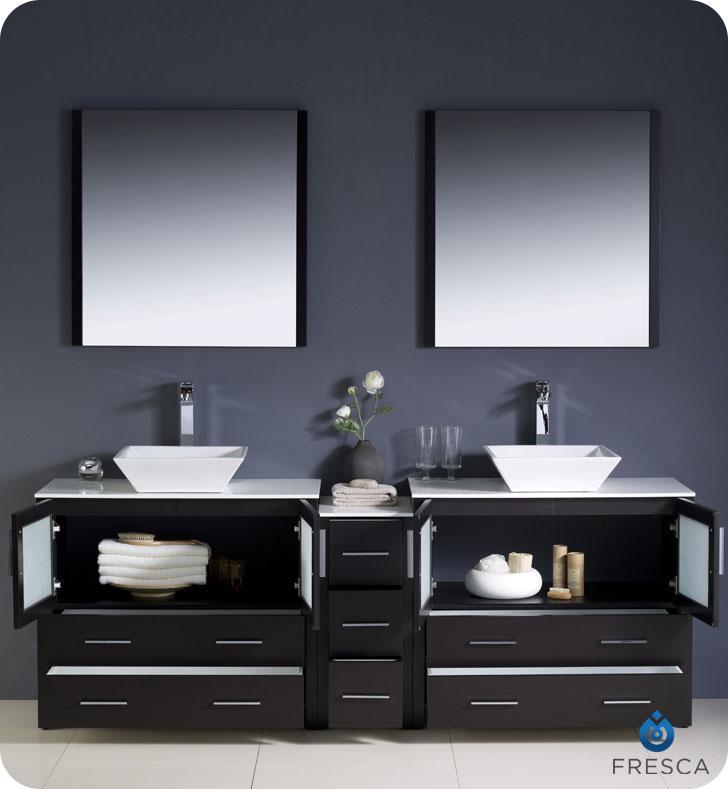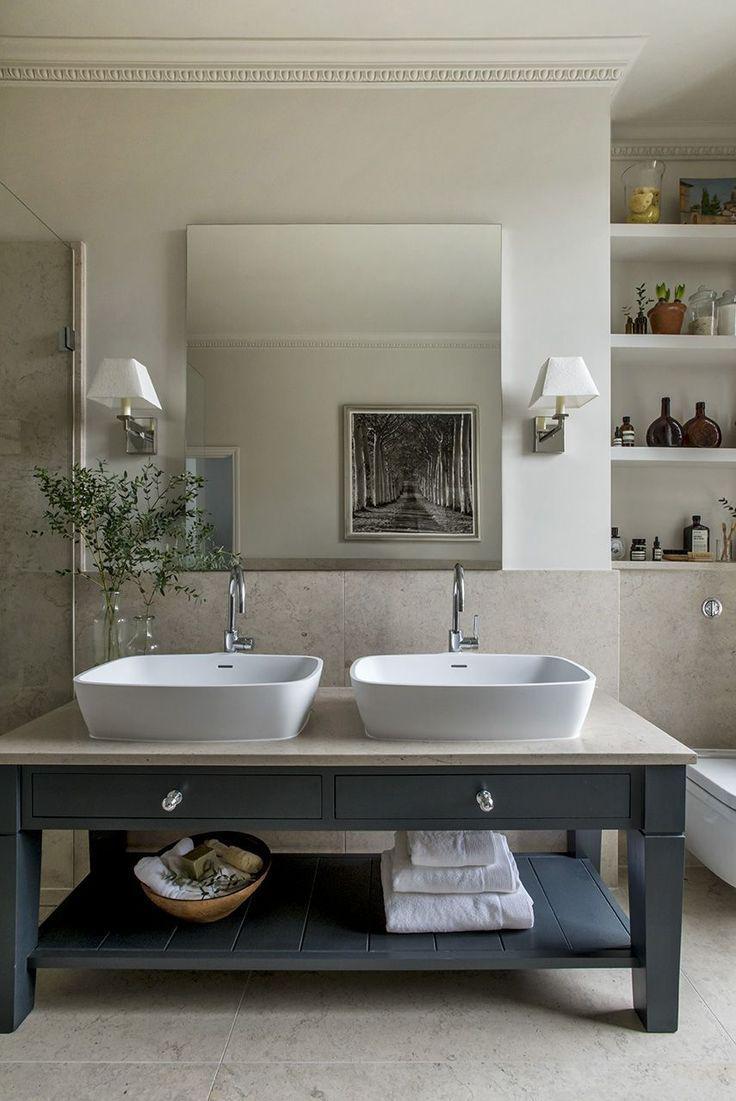The first image is the image on the left, the second image is the image on the right. Evaluate the accuracy of this statement regarding the images: "The vanity in the right-hand image features a pair of squarish white basins sitting on top.". Is it true? Answer yes or no. Yes. The first image is the image on the left, the second image is the image on the right. Assess this claim about the two images: "In one image, one large mirror is positioned over a long open wooden vanity on feet with two matching white sinks.". Correct or not? Answer yes or no. Yes. 